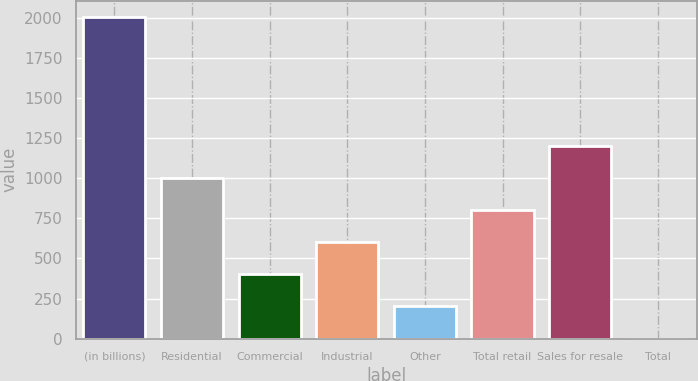Convert chart. <chart><loc_0><loc_0><loc_500><loc_500><bar_chart><fcel>(in billions)<fcel>Residential<fcel>Commercial<fcel>Industrial<fcel>Other<fcel>Total retail<fcel>Sales for resale<fcel>Total<nl><fcel>2004<fcel>1002.05<fcel>400.88<fcel>601.27<fcel>200.49<fcel>801.66<fcel>1202.44<fcel>0.1<nl></chart> 